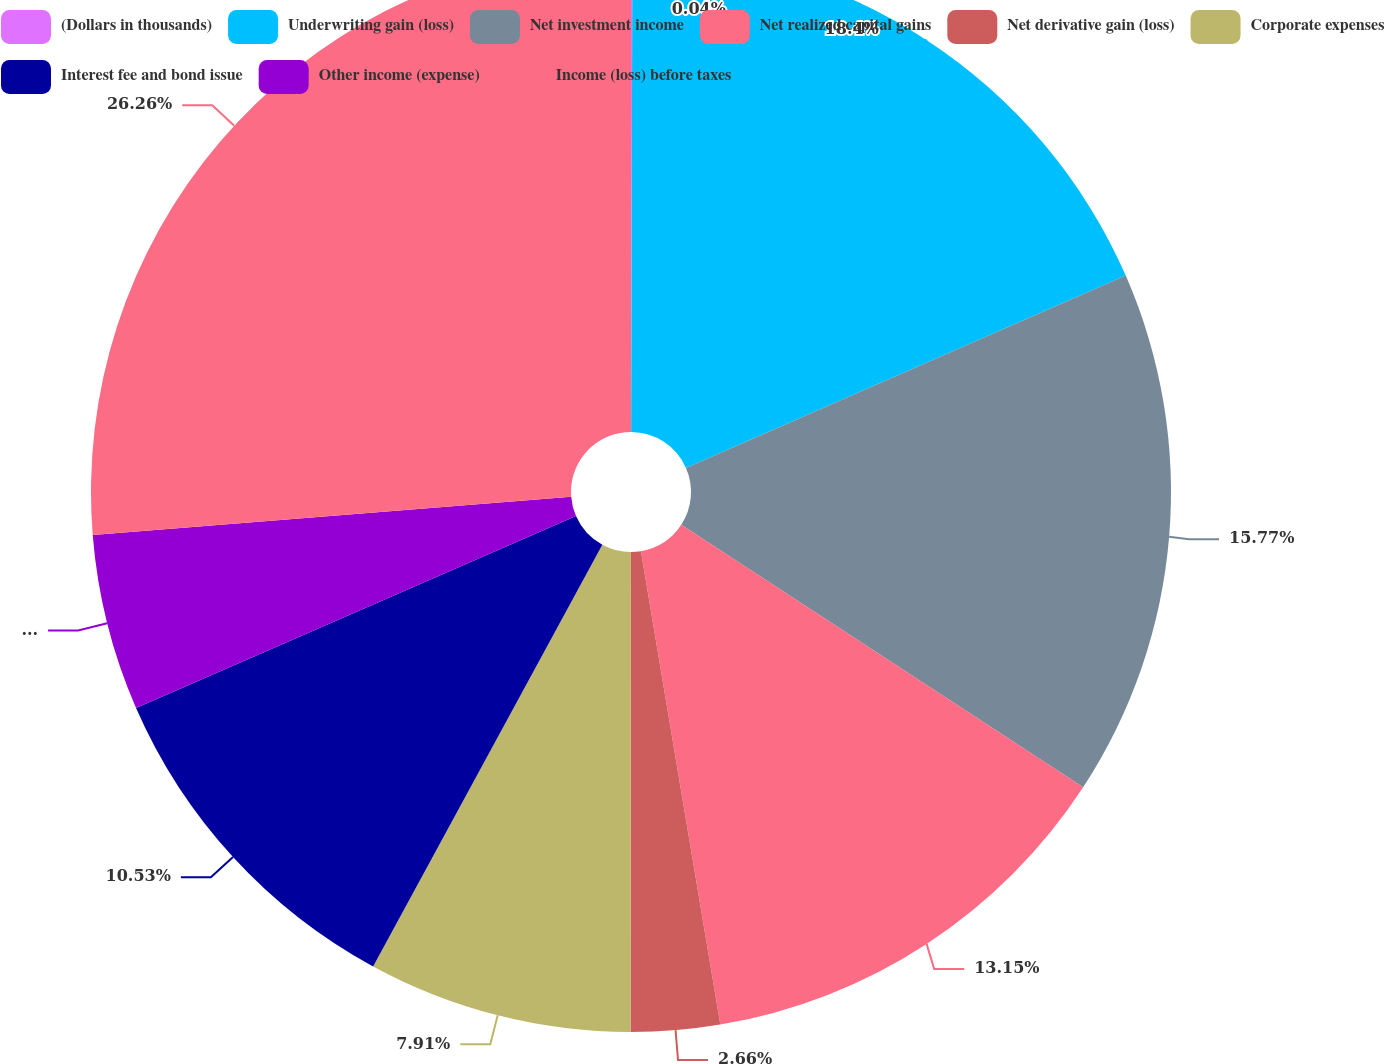Convert chart. <chart><loc_0><loc_0><loc_500><loc_500><pie_chart><fcel>(Dollars in thousands)<fcel>Underwriting gain (loss)<fcel>Net investment income<fcel>Net realized capital gains<fcel>Net derivative gain (loss)<fcel>Corporate expenses<fcel>Interest fee and bond issue<fcel>Other income (expense)<fcel>Income (loss) before taxes<nl><fcel>0.04%<fcel>18.4%<fcel>15.77%<fcel>13.15%<fcel>2.66%<fcel>7.91%<fcel>10.53%<fcel>5.28%<fcel>26.27%<nl></chart> 